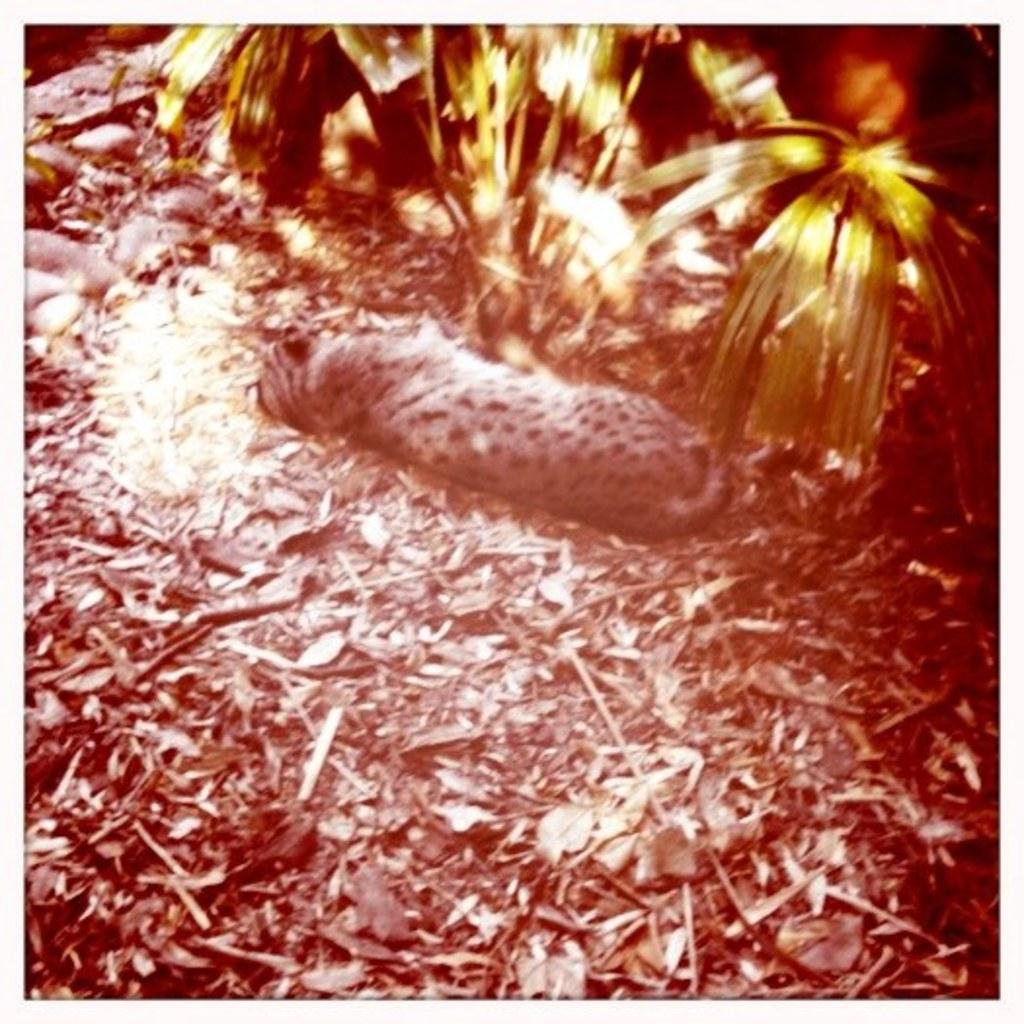Describe this image in one or two sentences. In this picture there is an animal sleeping and there is a plant in front of it and there are few dried leaves behind it. 